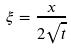<formula> <loc_0><loc_0><loc_500><loc_500>\xi = \frac { x } { 2 \sqrt { t } }</formula> 